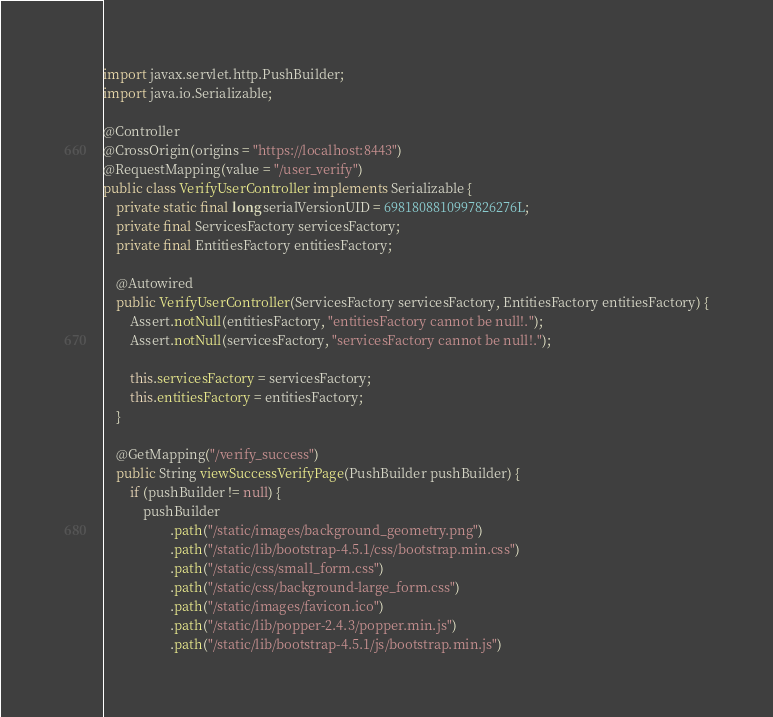<code> <loc_0><loc_0><loc_500><loc_500><_Java_>import javax.servlet.http.PushBuilder;
import java.io.Serializable;

@Controller
@CrossOrigin(origins = "https://localhost:8443")
@RequestMapping(value = "/user_verify")
public class VerifyUserController implements Serializable {
    private static final long serialVersionUID = 6981808810997826276L;
    private final ServicesFactory servicesFactory;
    private final EntitiesFactory entitiesFactory;

    @Autowired
    public VerifyUserController(ServicesFactory servicesFactory, EntitiesFactory entitiesFactory) {
        Assert.notNull(entitiesFactory, "entitiesFactory cannot be null!.");
        Assert.notNull(servicesFactory, "servicesFactory cannot be null!.");

        this.servicesFactory = servicesFactory;
        this.entitiesFactory = entitiesFactory;
    }

    @GetMapping("/verify_success")
    public String viewSuccessVerifyPage(PushBuilder pushBuilder) {
        if (pushBuilder != null) {
            pushBuilder
                    .path("/static/images/background_geometry.png")
                    .path("/static/lib/bootstrap-4.5.1/css/bootstrap.min.css")
                    .path("/static/css/small_form.css")
                    .path("/static/css/background-large_form.css")
                    .path("/static/images/favicon.ico")
                    .path("/static/lib/popper-2.4.3/popper.min.js")
                    .path("/static/lib/bootstrap-4.5.1/js/bootstrap.min.js")</code> 